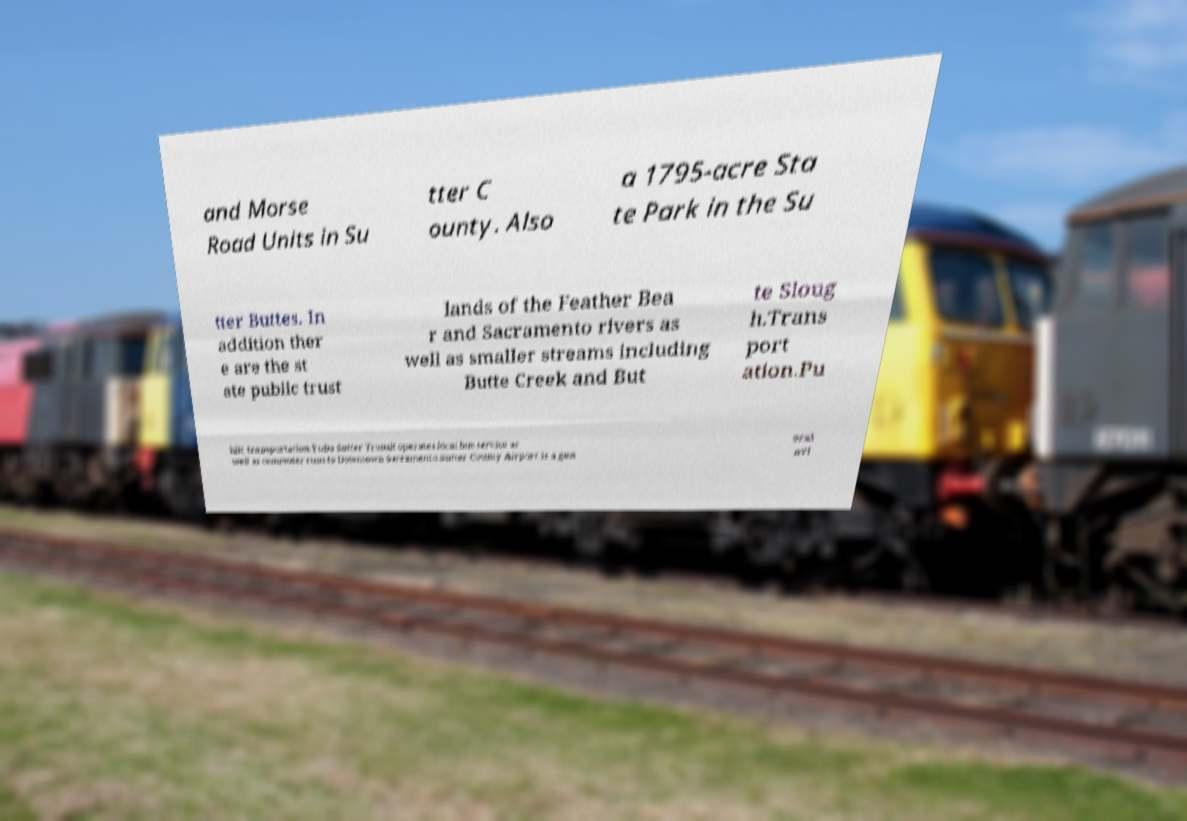Please read and relay the text visible in this image. What does it say? and Morse Road Units in Su tter C ounty. Also a 1795-acre Sta te Park in the Su tter Buttes. In addition ther e are the st ate public trust lands of the Feather Bea r and Sacramento rivers as well as smaller streams including Butte Creek and But te Sloug h.Trans port ation.Pu blic transportation.Yuba Sutter Transit operates local bus service as well as commuter runs to Downtown Sacramento.Sutter County Airport is a gen eral avi 